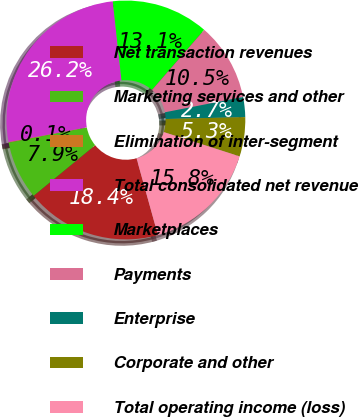<chart> <loc_0><loc_0><loc_500><loc_500><pie_chart><fcel>Net transaction revenues<fcel>Marketing services and other<fcel>Elimination of inter-segment<fcel>Total consolidated net revenue<fcel>Marketplaces<fcel>Payments<fcel>Enterprise<fcel>Corporate and other<fcel>Total operating income (loss)<nl><fcel>18.37%<fcel>7.92%<fcel>0.08%<fcel>26.2%<fcel>13.14%<fcel>10.53%<fcel>2.7%<fcel>5.31%<fcel>15.75%<nl></chart> 